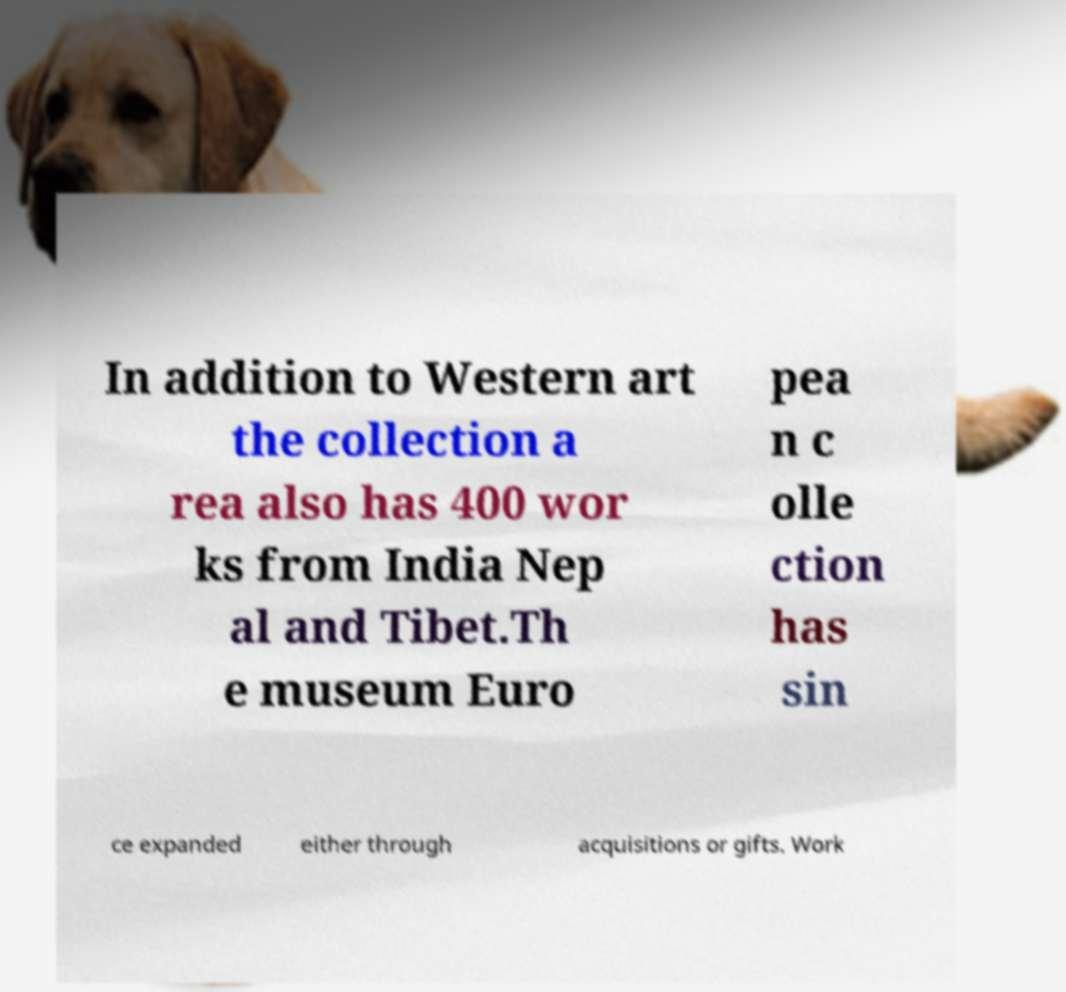What messages or text are displayed in this image? I need them in a readable, typed format. In addition to Western art the collection a rea also has 400 wor ks from India Nep al and Tibet.Th e museum Euro pea n c olle ction has sin ce expanded either through acquisitions or gifts. Work 